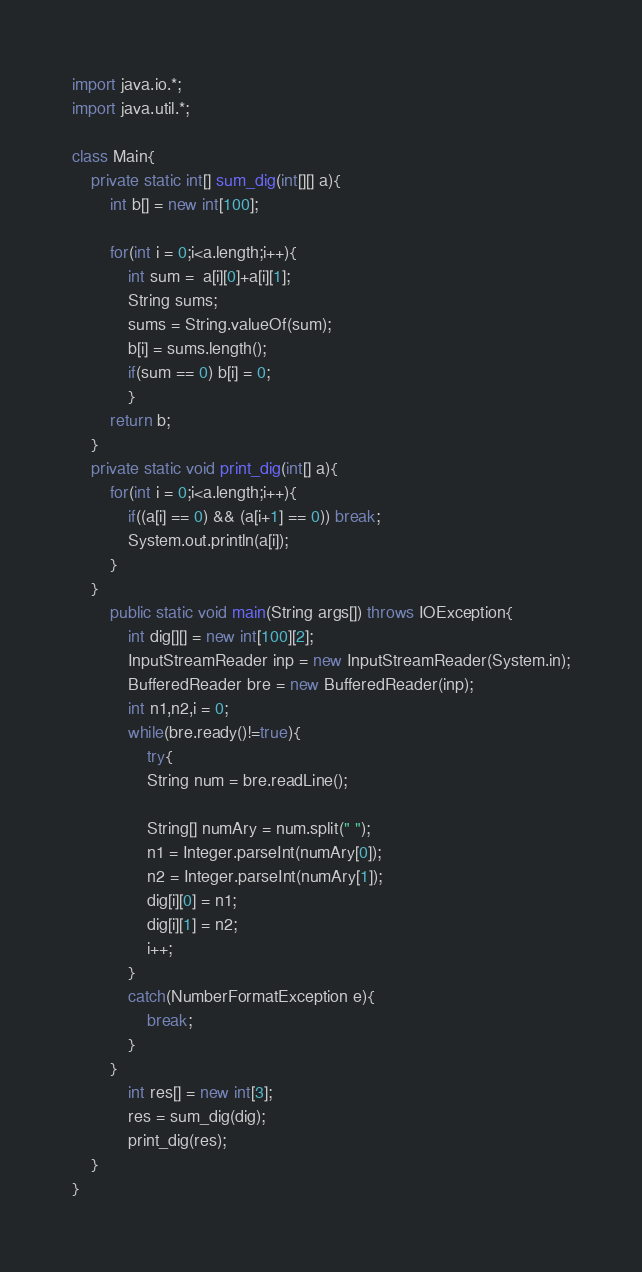Convert code to text. <code><loc_0><loc_0><loc_500><loc_500><_Java_>import java.io.*;
import java.util.*;

class Main{
	private static int[] sum_dig(int[][] a){
		int b[] = new int[100];
		
		for(int i = 0;i<a.length;i++){
			int sum =  a[i][0]+a[i][1];
			String sums;
			sums = String.valueOf(sum);
			b[i] = sums.length();
			if(sum == 0) b[i] = 0;
			}
		return b;
	}
	private static void print_dig(int[] a){
		for(int i = 0;i<a.length;i++){
			if((a[i] == 0) && (a[i+1] == 0)) break;
			System.out.println(a[i]);
		}
	}
		public static void main(String args[]) throws IOException{
			int dig[][] = new int[100][2];
			InputStreamReader inp = new InputStreamReader(System.in);
			BufferedReader bre = new BufferedReader(inp);
			int n1,n2,i = 0;
			while(bre.ready()!=true){
				try{
				String num = bre.readLine();
				
				String[] numAry = num.split(" ");
				n1 = Integer.parseInt(numAry[0]);
				n2 = Integer.parseInt(numAry[1]);
				dig[i][0] = n1;
				dig[i][1] = n2;
				i++;
			}
			catch(NumberFormatException e){
				break;
			}
		}
			int res[] = new int[3];
			res = sum_dig(dig);
			print_dig(res);
	}
}</code> 